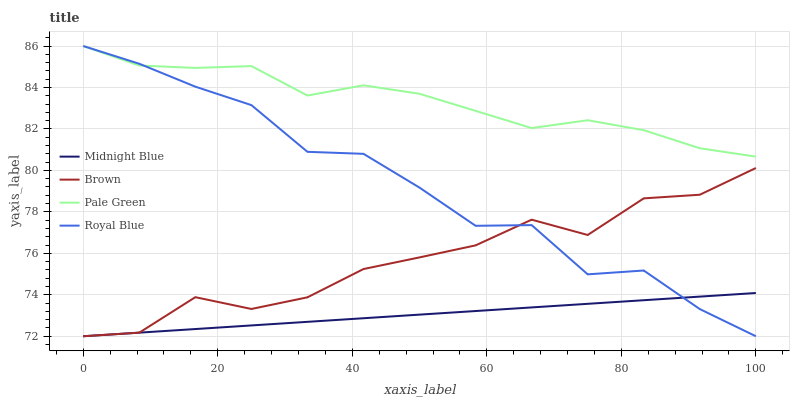Does Midnight Blue have the minimum area under the curve?
Answer yes or no. Yes. Does Pale Green have the maximum area under the curve?
Answer yes or no. Yes. Does Pale Green have the minimum area under the curve?
Answer yes or no. No. Does Midnight Blue have the maximum area under the curve?
Answer yes or no. No. Is Midnight Blue the smoothest?
Answer yes or no. Yes. Is Royal Blue the roughest?
Answer yes or no. Yes. Is Pale Green the smoothest?
Answer yes or no. No. Is Pale Green the roughest?
Answer yes or no. No. Does Brown have the lowest value?
Answer yes or no. Yes. Does Pale Green have the lowest value?
Answer yes or no. No. Does Royal Blue have the highest value?
Answer yes or no. Yes. Does Midnight Blue have the highest value?
Answer yes or no. No. Is Midnight Blue less than Pale Green?
Answer yes or no. Yes. Is Pale Green greater than Brown?
Answer yes or no. Yes. Does Brown intersect Midnight Blue?
Answer yes or no. Yes. Is Brown less than Midnight Blue?
Answer yes or no. No. Is Brown greater than Midnight Blue?
Answer yes or no. No. Does Midnight Blue intersect Pale Green?
Answer yes or no. No. 